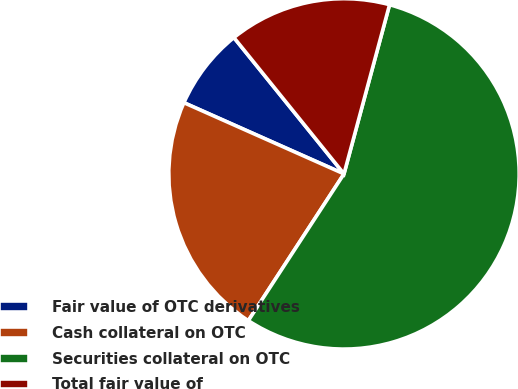Convert chart. <chart><loc_0><loc_0><loc_500><loc_500><pie_chart><fcel>Fair value of OTC derivatives<fcel>Cash collateral on OTC<fcel>Securities collateral on OTC<fcel>Total fair value of<nl><fcel>7.53%<fcel>22.47%<fcel>55.01%<fcel>15.0%<nl></chart> 